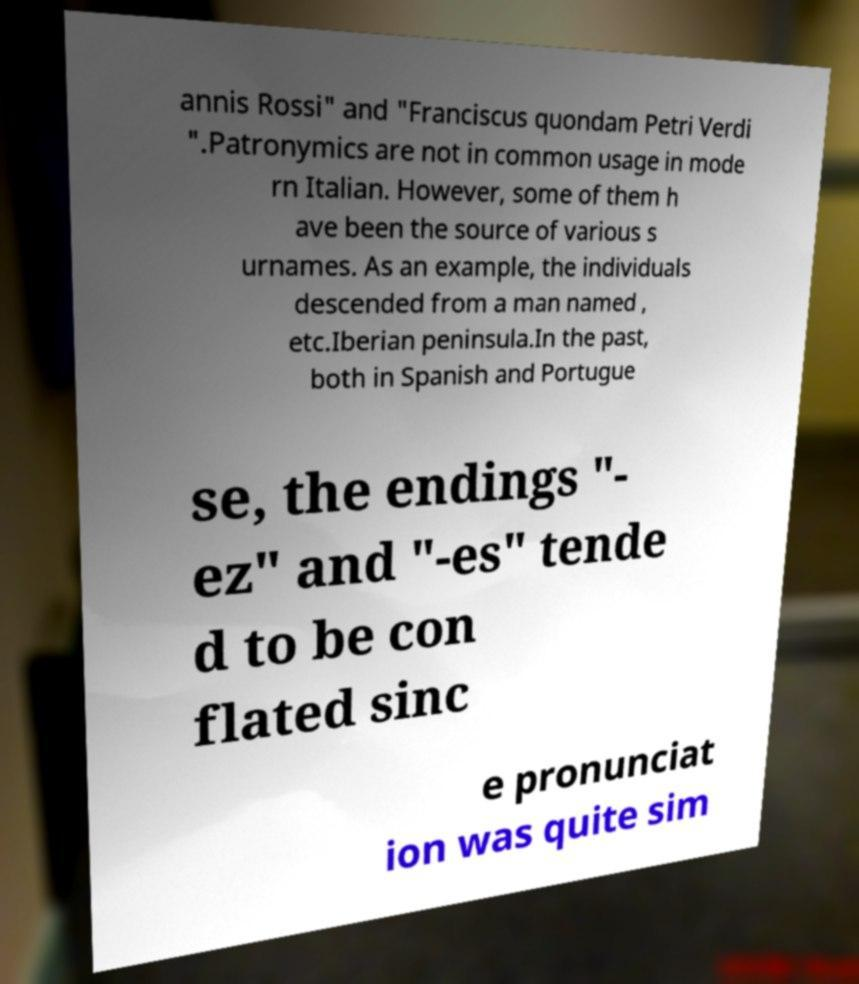For documentation purposes, I need the text within this image transcribed. Could you provide that? annis Rossi" and "Franciscus quondam Petri Verdi ".Patronymics are not in common usage in mode rn Italian. However, some of them h ave been the source of various s urnames. As an example, the individuals descended from a man named , etc.Iberian peninsula.In the past, both in Spanish and Portugue se, the endings "- ez" and "-es" tende d to be con flated sinc e pronunciat ion was quite sim 